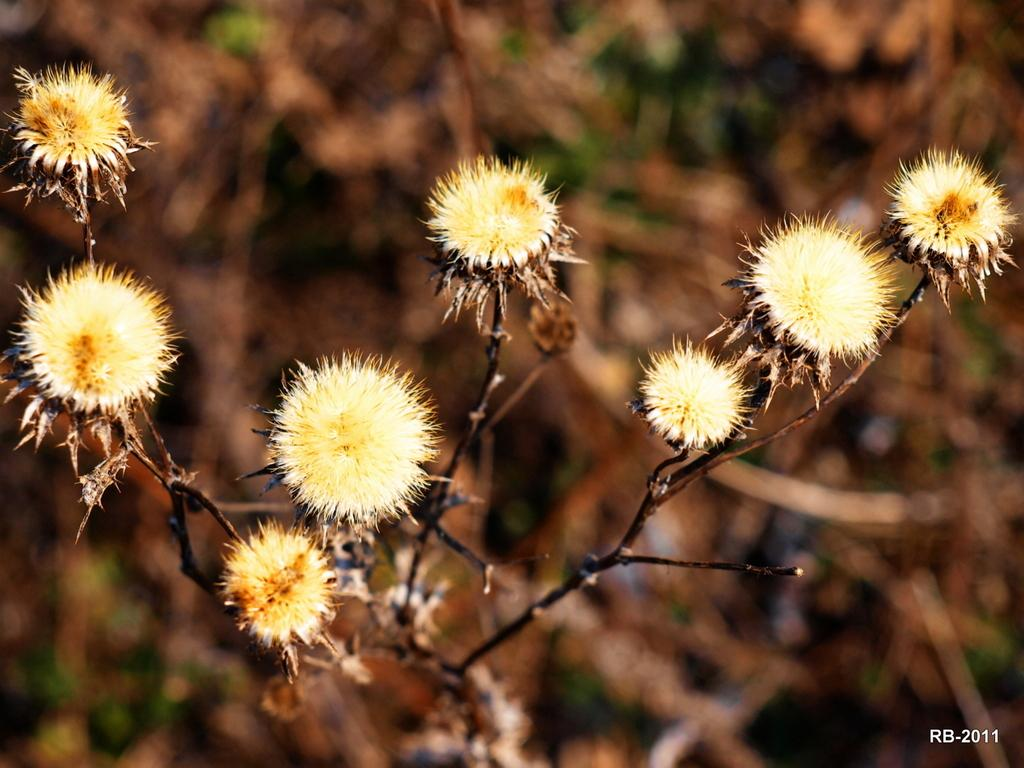What type of living organisms can be seen in the image? There are flowers and a plant visible in the image. How is the background of the image depicted? The background of the image is blurred. Where can some text be found in the image? There is some text in the bottom right side of the image. What type of steel object can be seen in the image? There is no steel object present in the image. How does the soap interact with the flowers in the image? There is no soap present in the image, so it cannot interact with the flowers. 